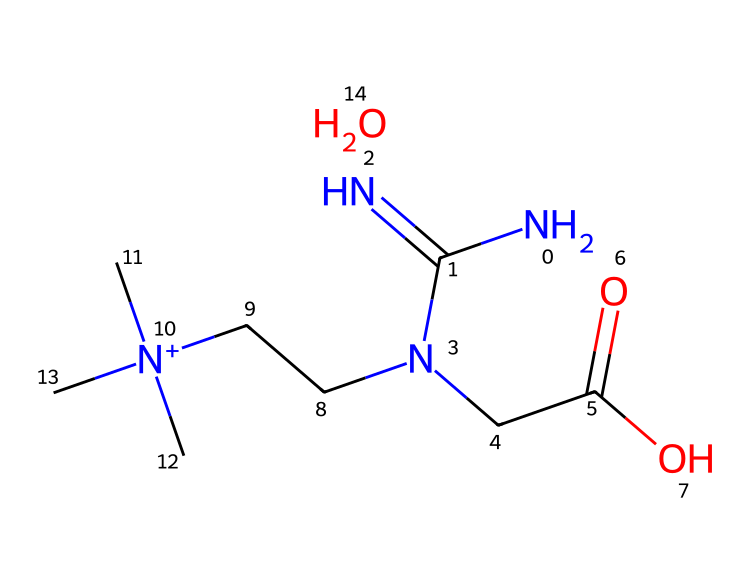how many nitrogen atoms are present in creatine monohydrate? In the SMILES representation, "N" indicates nitrogen atoms. Counting the occurrences of "N", we find there are a total of 4 nitrogen atoms present in the structure.
Answer: 4 what is the functional group present in creatine monohydrate? The presence of "C(=O)O" in the SMILES indicates the presence of a carboxylic acid functional group. This is identified by the carbon double bonded to an oxygen atom (carbonyl) and single bonded to a hydroxyl group (–OH).
Answer: carboxylic acid how many carbon atoms are in creatine monohydrate? By analyzing the SMILES representation, we count the "C" atoms. There are 6 carbon atoms present as they are represented clearly in the structure.
Answer: 6 which atoms are positively charged in the molecule? The "[N+](C)(C)C" segment indicates the presence of a positively charged nitrogen atom, which has a charge due to its bonding with three carbon atoms.
Answer: nitrogen what is the role of creatine monohydrate in athletic performance? Creatine monohydrate is primarily used as a supplement to enhance energy production in muscles during high-intensity exercise, improving strength and potentially aiding in recovery.
Answer: energy production does creatine monohydrate contain any elements other than carbon, hydrogen, nitrogen, and oxygen? The chemical structure provided only includes carbon (C), hydrogen (H), nitrogen (N), and oxygen (O). No other elements are present in the structure.
Answer: no what structural feature indicates that creatine monohydrate is effective in short bursts of energy? The presence of the "CC[N+](C)(C)C" segment indicates that the structure allows for rapid energy synthesis, provided by the ability of creatine to donate high-energy phosphate for ATP (adenosine triphosphate) production in muscle cells.
Answer: rapid energy synthesis 